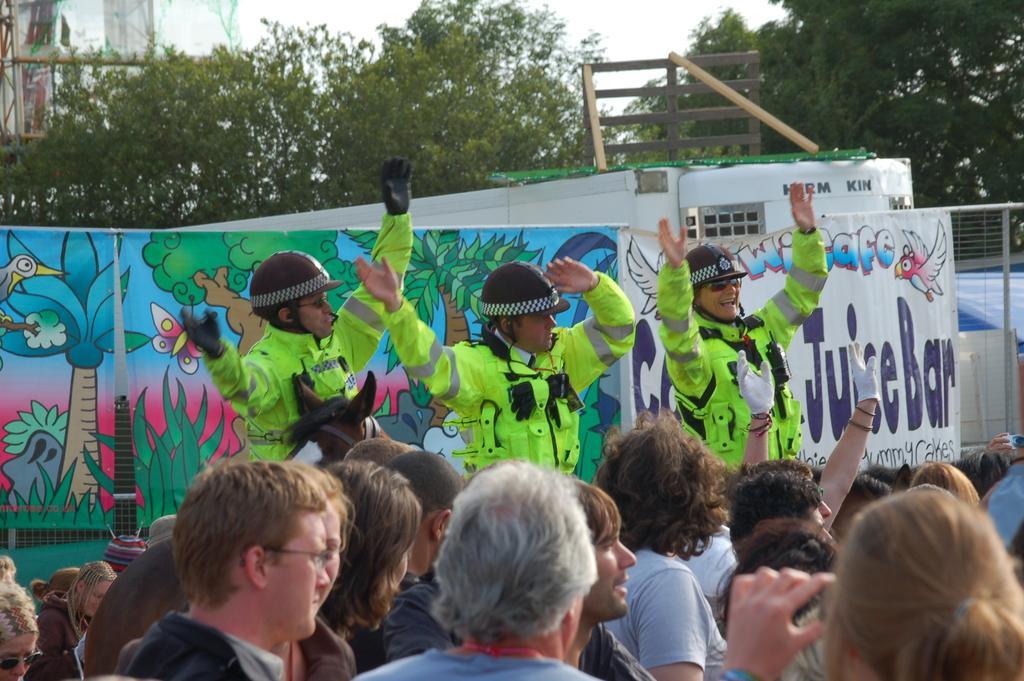Please provide a concise description of this image. In this image we can see a horse and three people standing wearing the helmets and uniform. At the bottom of the image we can see a group of people. In that a woman is holding a device. On the backside we can see a metal fence, some banners with the pictures and some text on them, a wooden frame, a group of trees, a poster and the sky which looks cloudy. 